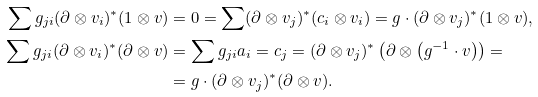Convert formula to latex. <formula><loc_0><loc_0><loc_500><loc_500>& & \sum g _ { j i } ( \partial \otimes v _ { i } ) ^ { * } ( 1 \otimes v ) & = 0 = \sum ( \partial \otimes v _ { j } ) ^ { * } ( c _ { i } \otimes v _ { i } ) = g \cdot ( \partial \otimes v _ { j } ) ^ { * } ( 1 \otimes v ) , \\ & & \sum g _ { j i } ( \partial \otimes v _ { i } ) ^ { * } ( \partial \otimes v ) & = \sum g _ { j i } a _ { i } = c _ { j } = ( \partial \otimes v _ { j } ) ^ { * } \left ( \partial \otimes \left ( g ^ { - 1 } \cdot v \right ) \right ) = \\ & & & = g \cdot ( \partial \otimes v _ { j } ) ^ { * } ( \partial \otimes v ) .</formula> 